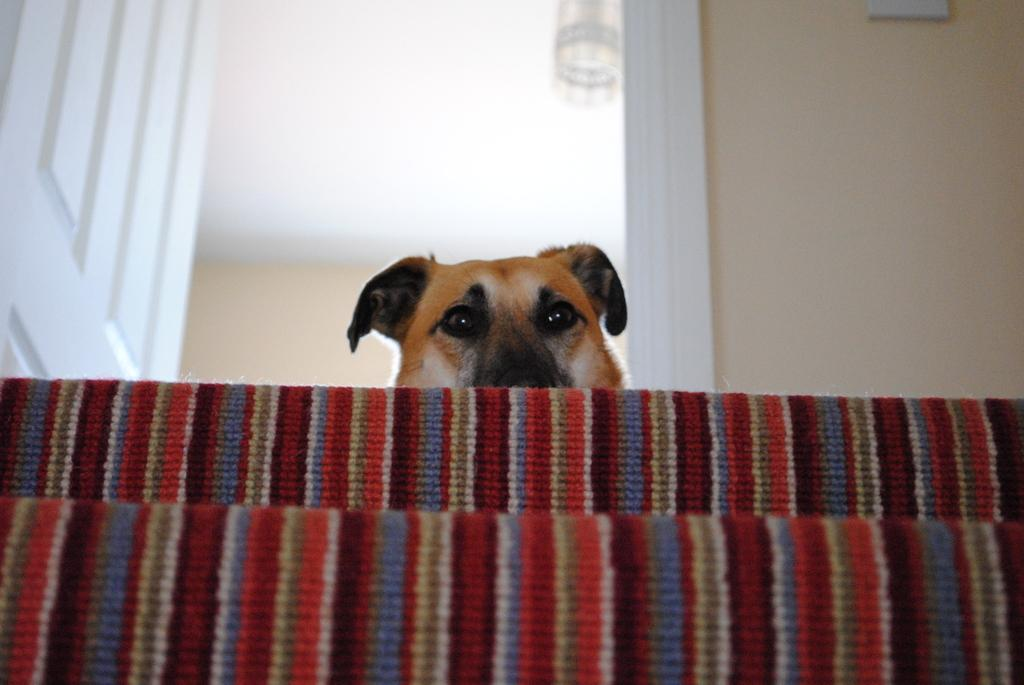What is located in the front of the image? There are mats in the front of the image. What is the main subject in the center of the image? There is a dog in the center of the image. What can be seen in the background of the image? There is a wall in the background of the image. Where is the door located in the image? The door is on the left side of the image. What color is the door? The door is white in color. Can you tell me how many owls are perched on the wall in the image? There are no owls present in the image; it features a dog, mats, a wall, and a door. What type of arithmetic problem is the dog solving in the image? There is no arithmetic problem present in the image; it features a dog, mats, a wall, and a door. 